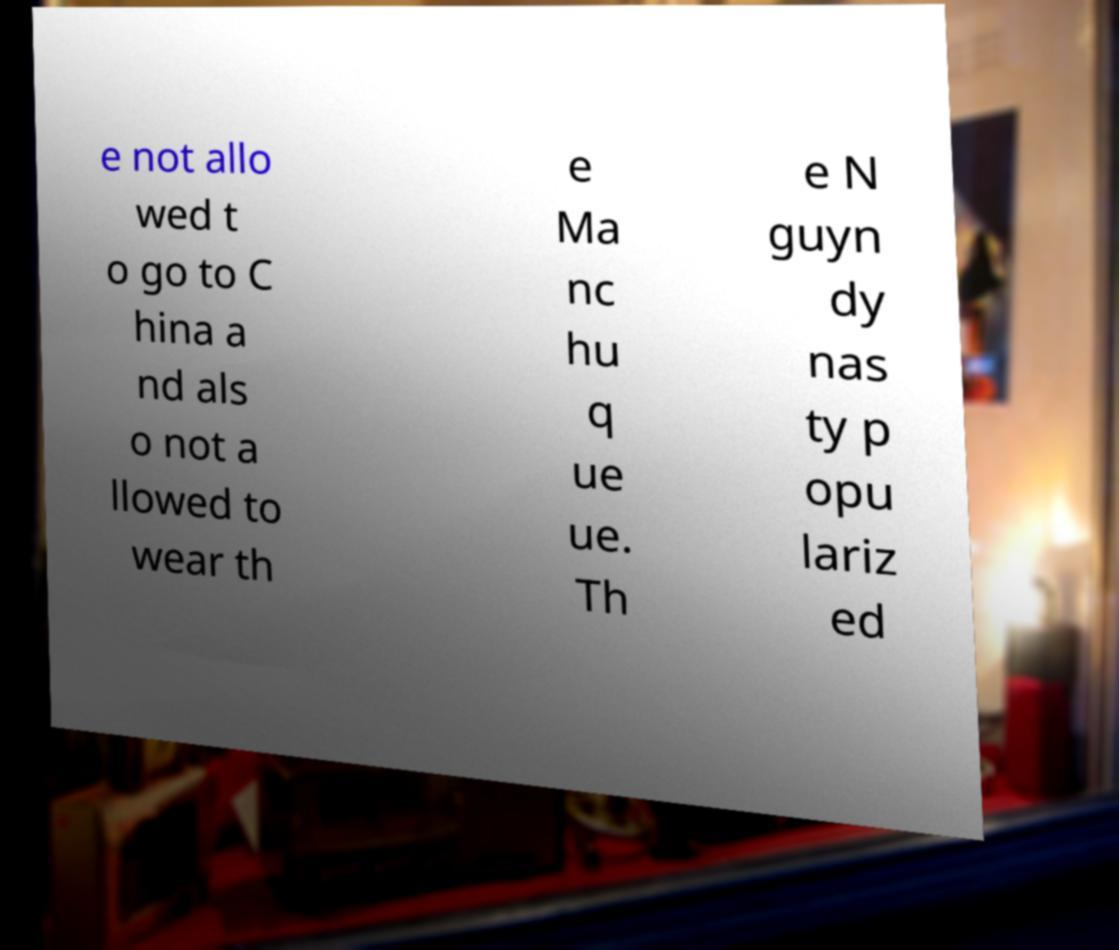Could you assist in decoding the text presented in this image and type it out clearly? e not allo wed t o go to C hina a nd als o not a llowed to wear th e Ma nc hu q ue ue. Th e N guyn dy nas ty p opu lariz ed 